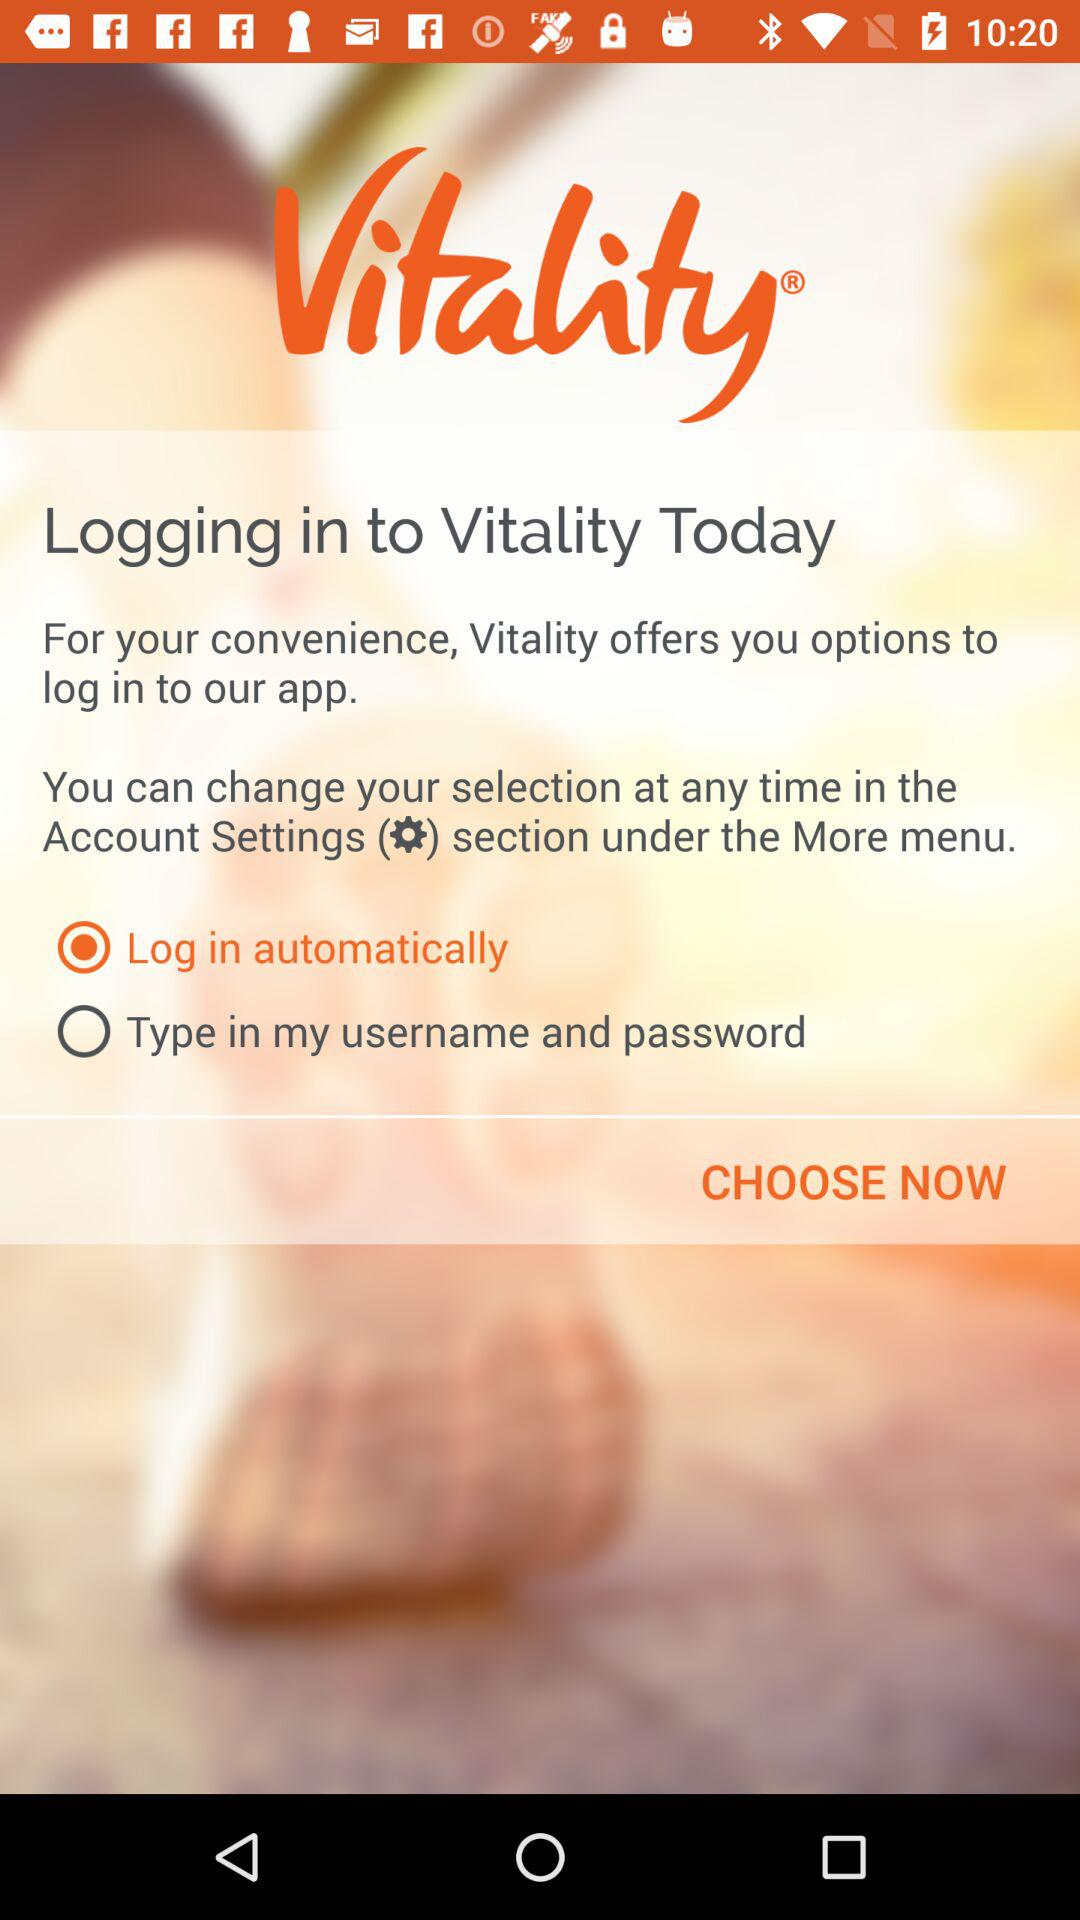What is the name of the application? The name of the application is "Vitality". 